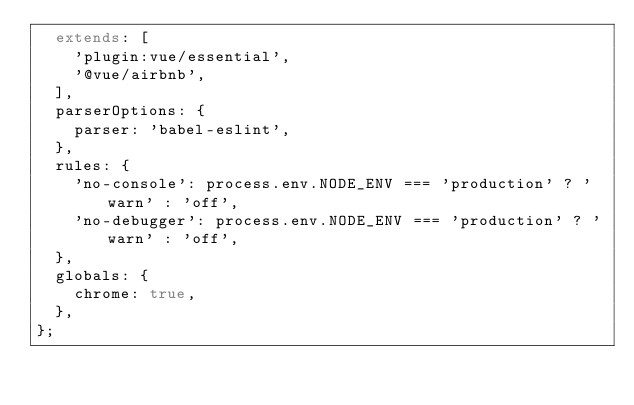Convert code to text. <code><loc_0><loc_0><loc_500><loc_500><_JavaScript_>  extends: [
    'plugin:vue/essential',
    '@vue/airbnb',
  ],
  parserOptions: {
    parser: 'babel-eslint',
  },
  rules: {
    'no-console': process.env.NODE_ENV === 'production' ? 'warn' : 'off',
    'no-debugger': process.env.NODE_ENV === 'production' ? 'warn' : 'off',
  },
  globals: {
    chrome: true,
  },
};
</code> 